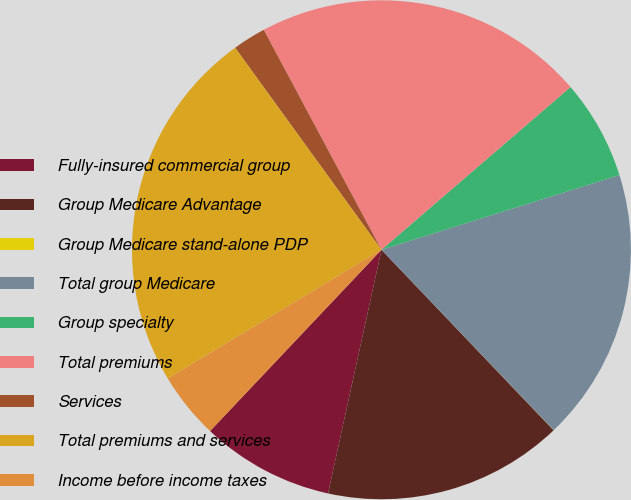Convert chart. <chart><loc_0><loc_0><loc_500><loc_500><pie_chart><fcel>Fully-insured commercial group<fcel>Group Medicare Advantage<fcel>Group Medicare stand-alone PDP<fcel>Total group Medicare<fcel>Group specialty<fcel>Total premiums<fcel>Services<fcel>Total premiums and services<fcel>Income before income taxes<nl><fcel>8.62%<fcel>15.56%<fcel>0.01%<fcel>17.71%<fcel>6.47%<fcel>21.51%<fcel>2.16%<fcel>23.66%<fcel>4.31%<nl></chart> 